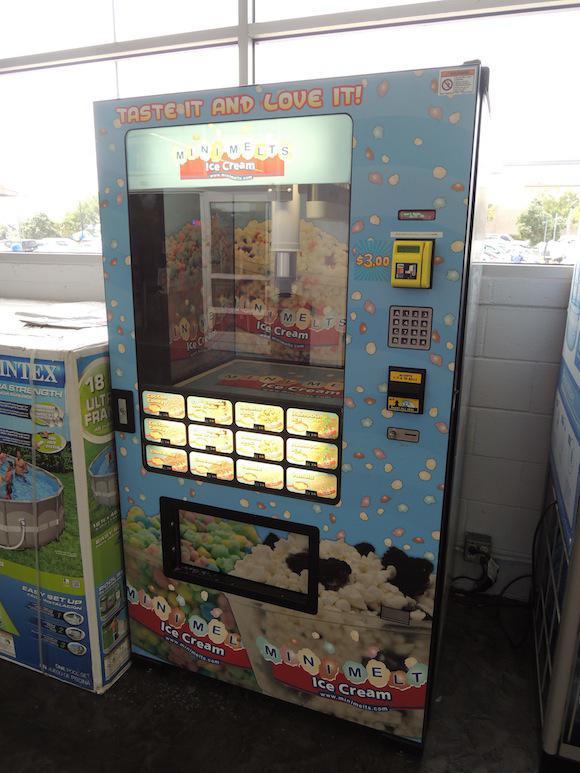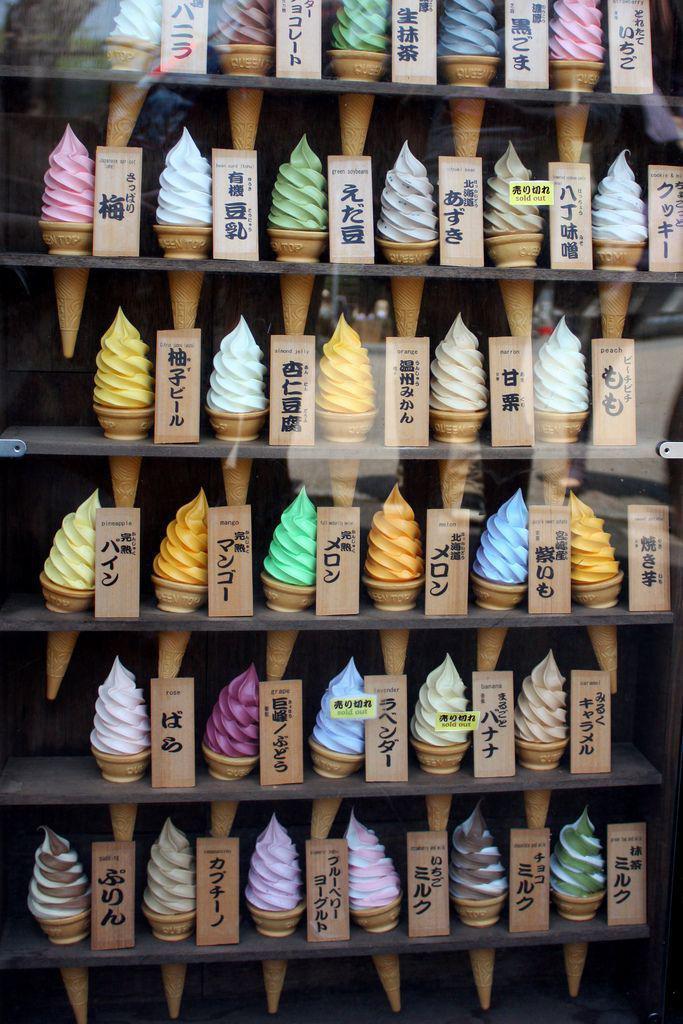The first image is the image on the left, the second image is the image on the right. Evaluate the accuracy of this statement regarding the images: "The dispensing port of the vending machine in the image on the right is oval.". Is it true? Answer yes or no. No. 